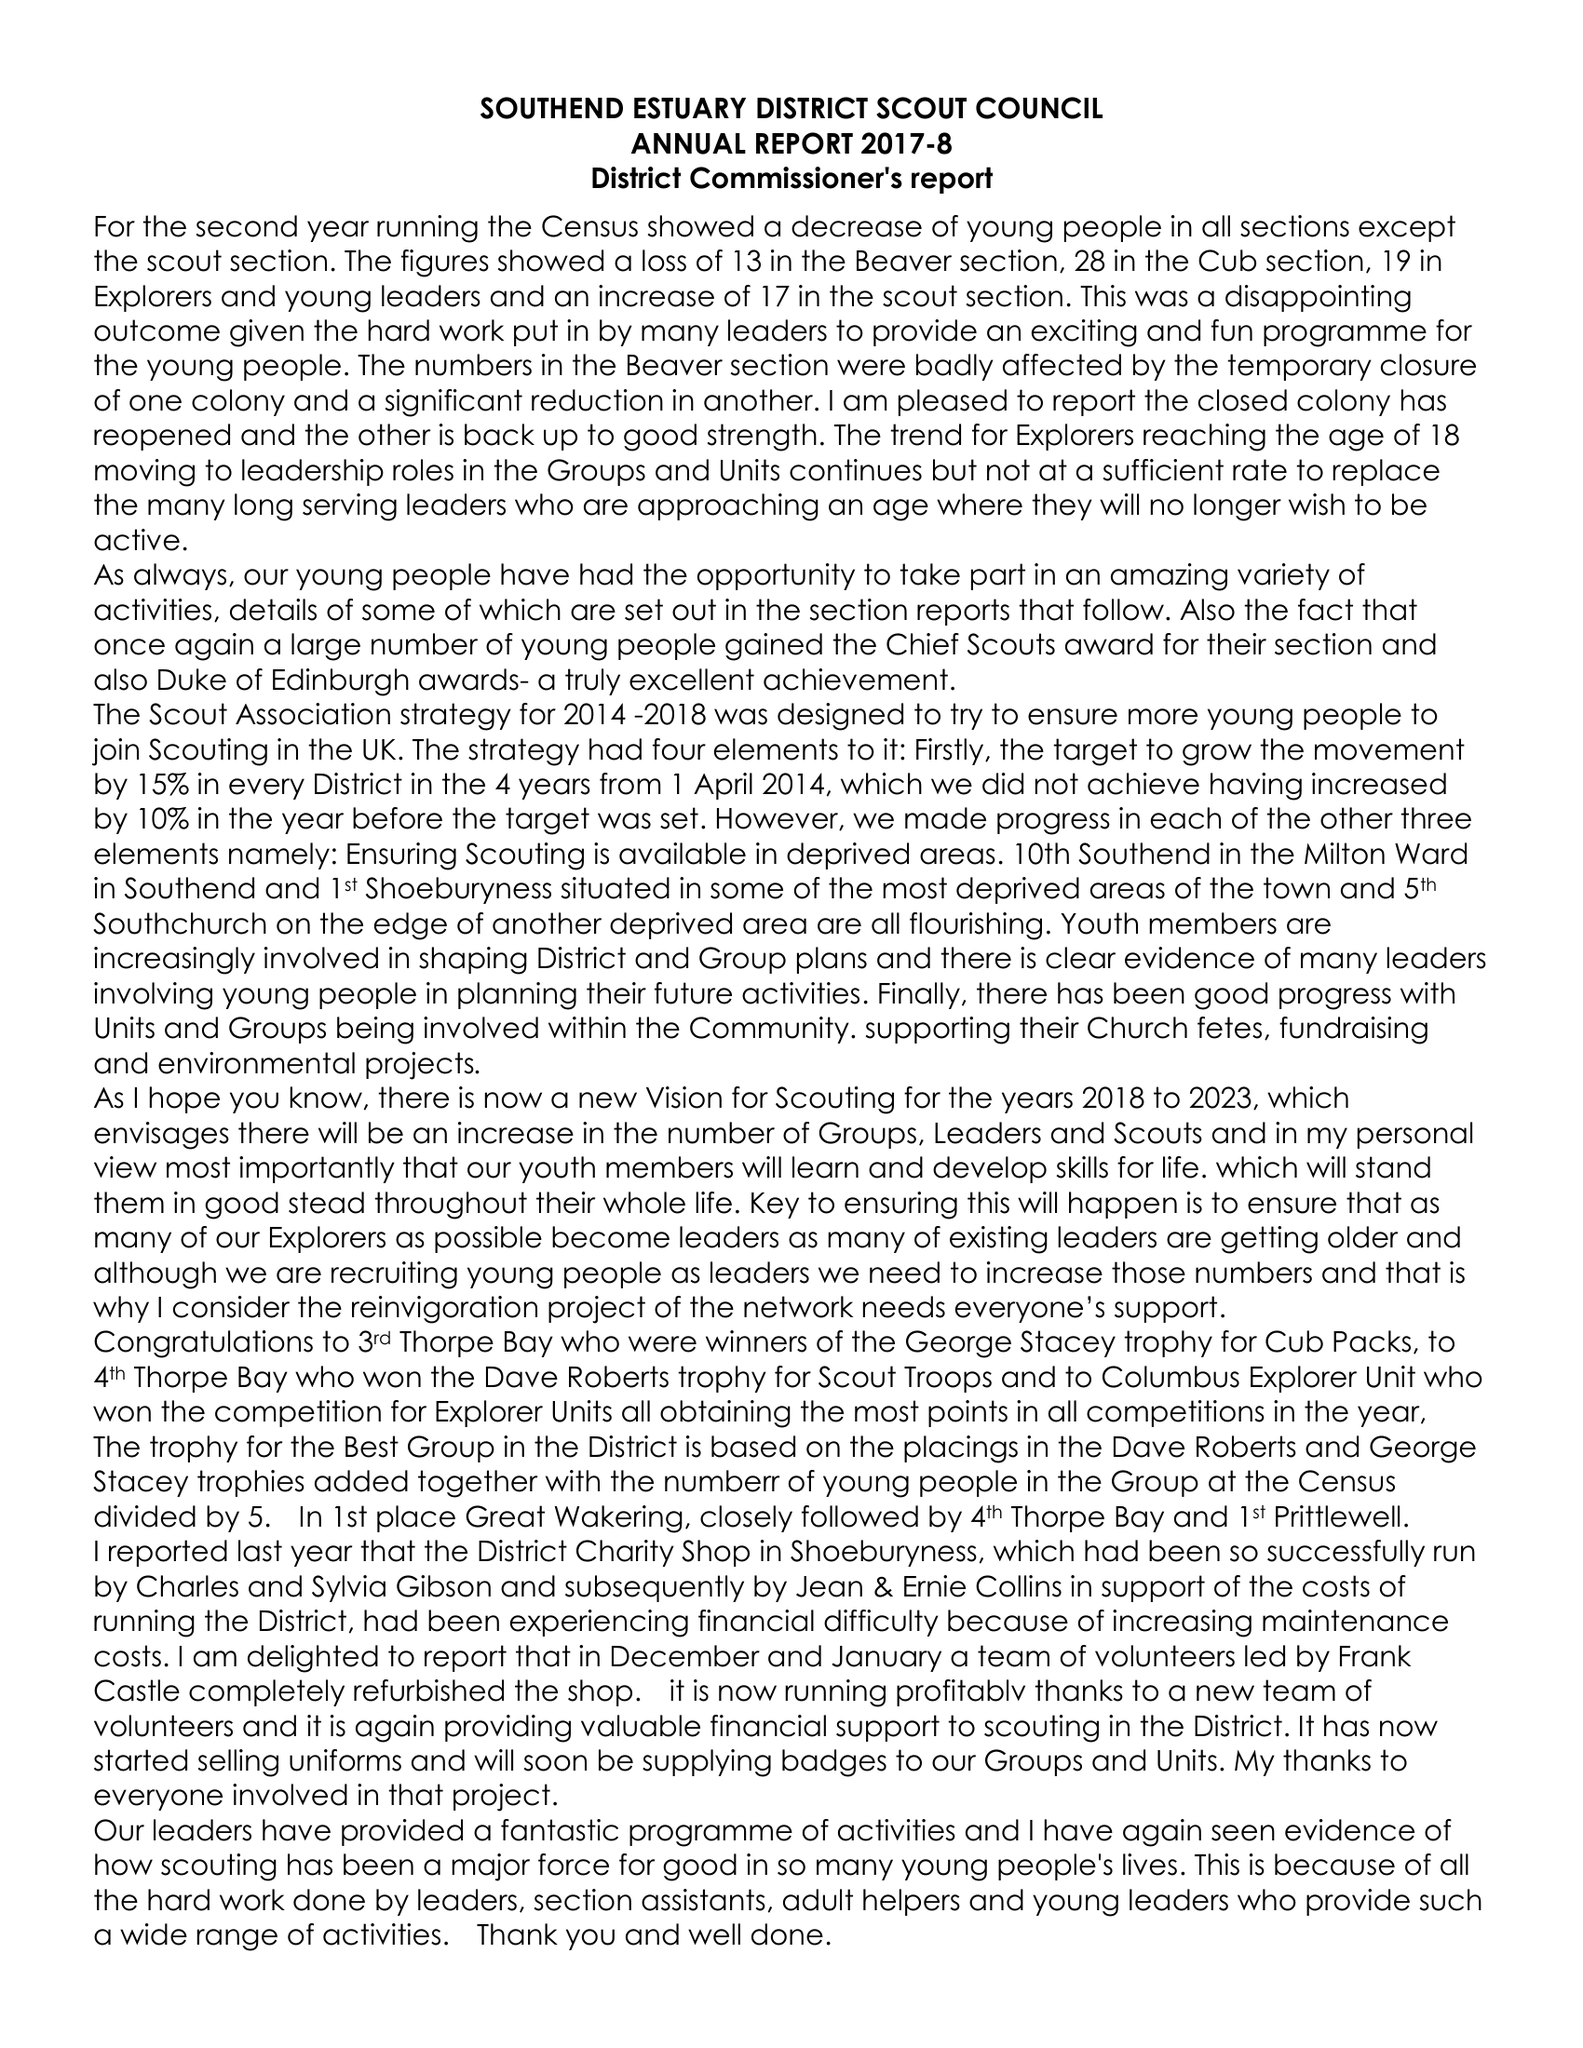What is the value for the address__postcode?
Answer the question using a single word or phrase. SS2 4NH 